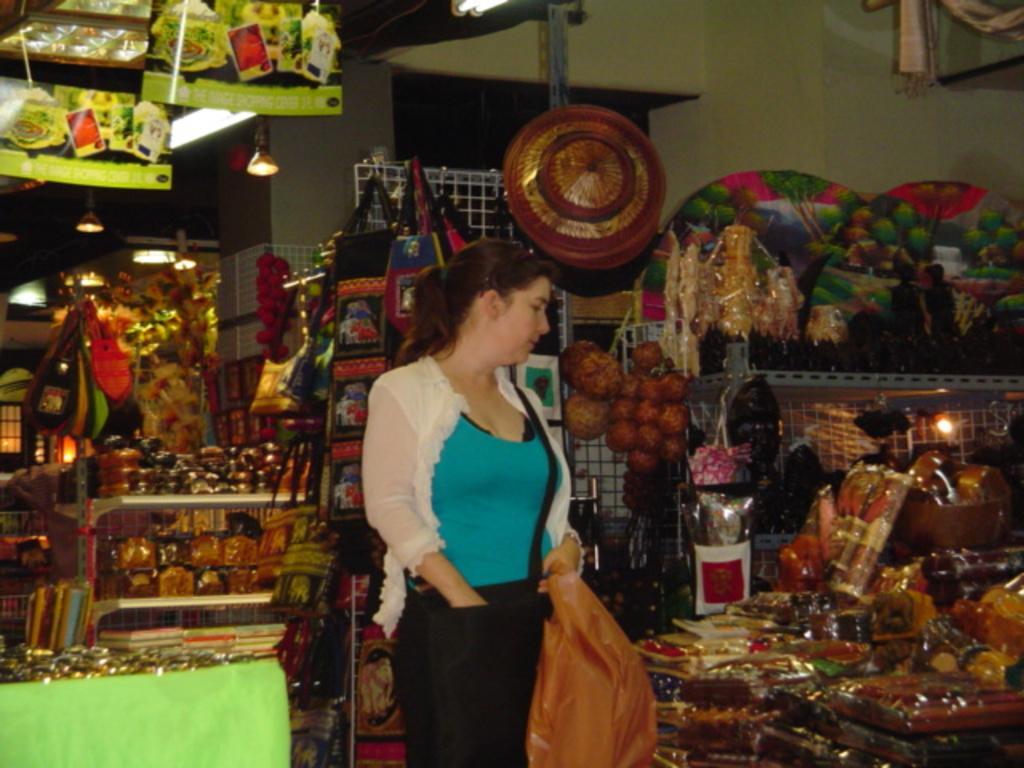Can you describe this image briefly? This picture seems to be clicked inside the hall. In the center we can see a woman wearing t-shirt, holding a plastic bag and standing and we can see the metal racks containing some food items and many other objects and there are some objects hanging on the metal rods. In the background we can see the wall, lights and many number of objects. 